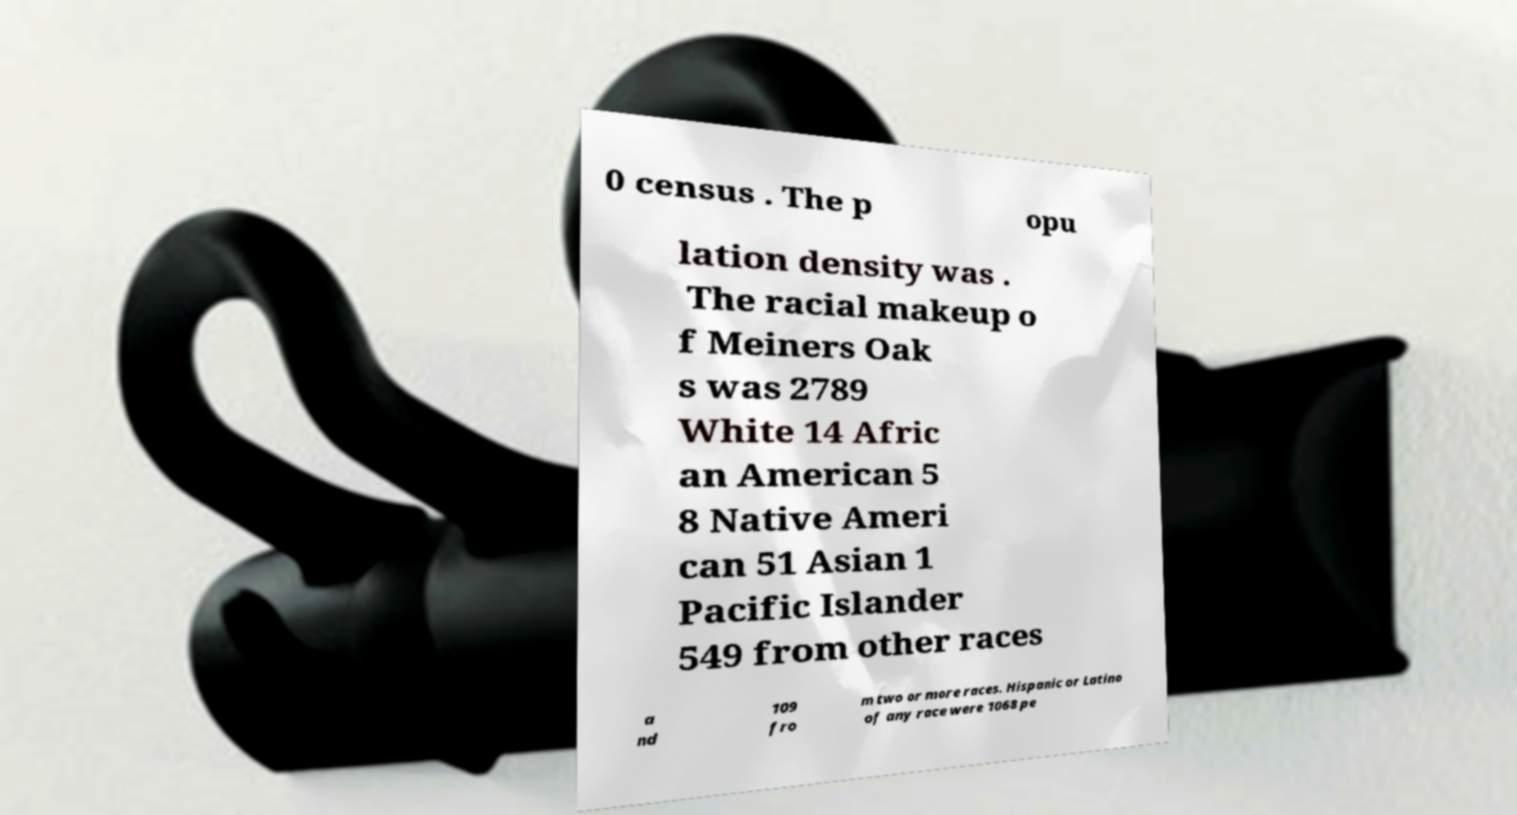Could you assist in decoding the text presented in this image and type it out clearly? 0 census . The p opu lation density was . The racial makeup o f Meiners Oak s was 2789 White 14 Afric an American 5 8 Native Ameri can 51 Asian 1 Pacific Islander 549 from other races a nd 109 fro m two or more races. Hispanic or Latino of any race were 1068 pe 